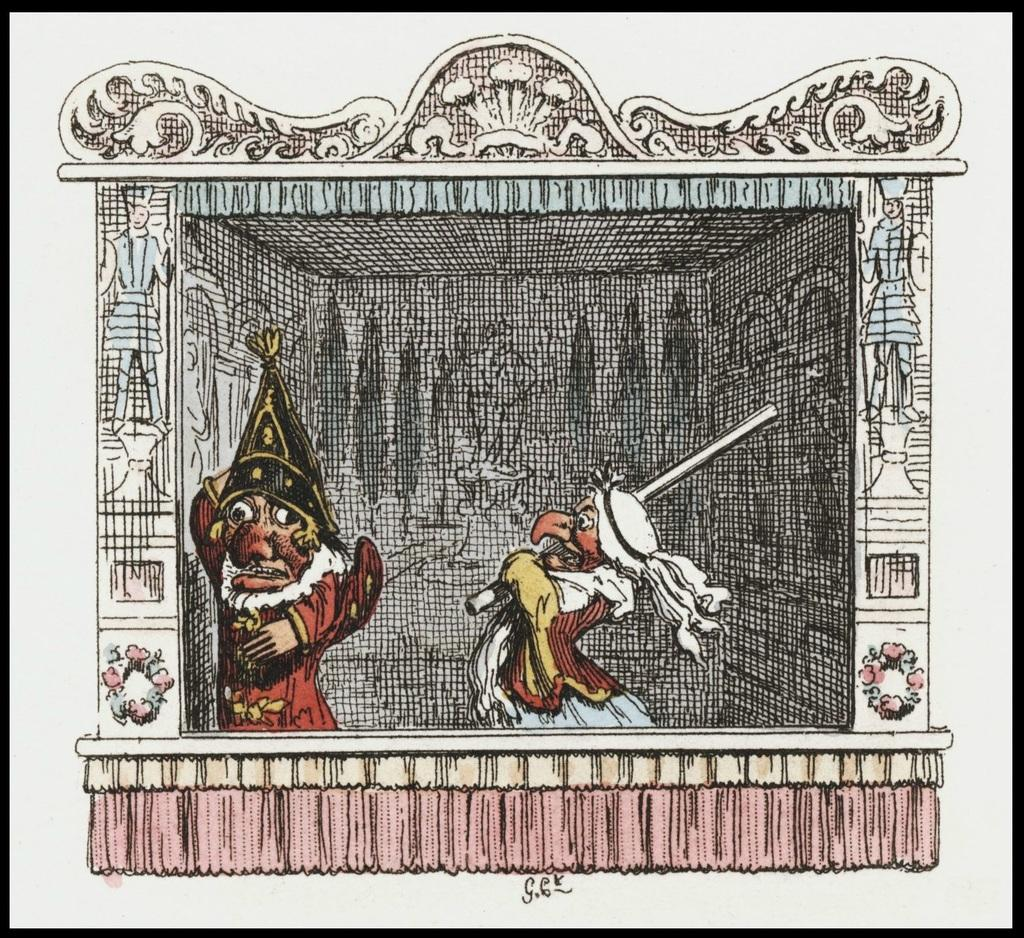What types of subjects are depicted in the image? There are depictions of people and flowers in the image. What is a person in the image holding? There is a person holding a stick in the image. How would you describe the background of the image? The background of the image is messy and in black color. What type of ornament is hanging from the zebra's neck in the image? There is no zebra present in the image, and therefore no ornament hanging from its neck. 